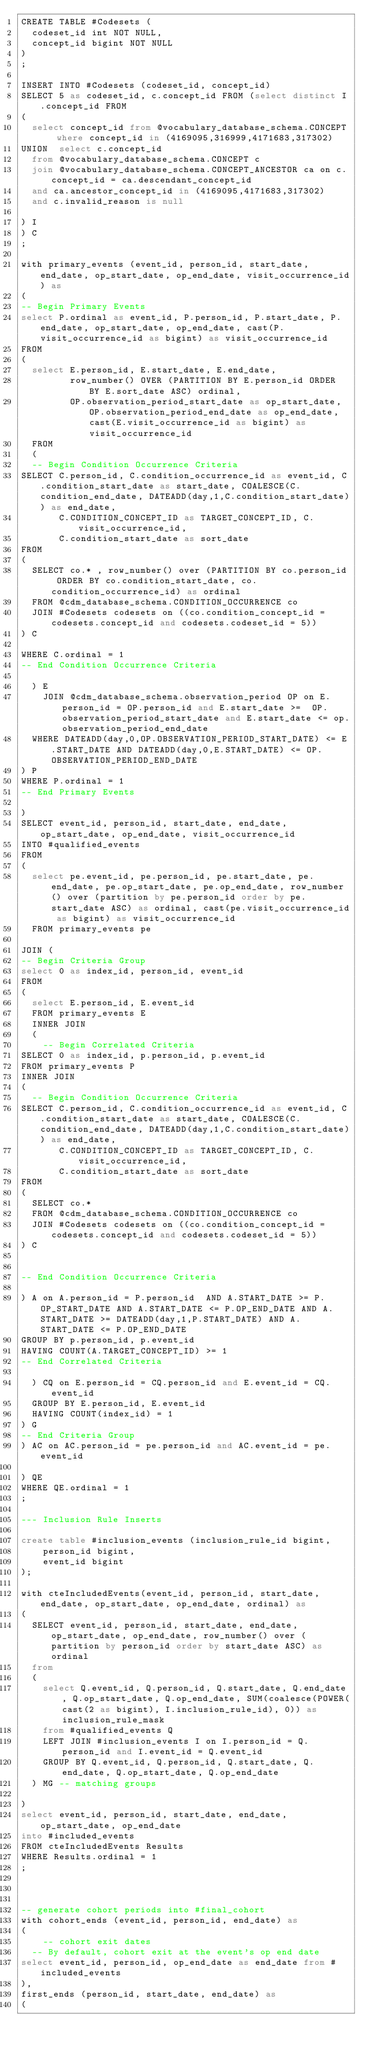<code> <loc_0><loc_0><loc_500><loc_500><_SQL_>CREATE TABLE #Codesets (
  codeset_id int NOT NULL,
  concept_id bigint NOT NULL
)
;

INSERT INTO #Codesets (codeset_id, concept_id)
SELECT 5 as codeset_id, c.concept_id FROM (select distinct I.concept_id FROM
( 
  select concept_id from @vocabulary_database_schema.CONCEPT where concept_id in (4169095,316999,4171683,317302)
UNION  select c.concept_id
  from @vocabulary_database_schema.CONCEPT c
  join @vocabulary_database_schema.CONCEPT_ANCESTOR ca on c.concept_id = ca.descendant_concept_id
  and ca.ancestor_concept_id in (4169095,4171683,317302)
  and c.invalid_reason is null

) I
) C
;

with primary_events (event_id, person_id, start_date, end_date, op_start_date, op_end_date, visit_occurrence_id) as
(
-- Begin Primary Events
select P.ordinal as event_id, P.person_id, P.start_date, P.end_date, op_start_date, op_end_date, cast(P.visit_occurrence_id as bigint) as visit_occurrence_id
FROM
(
  select E.person_id, E.start_date, E.end_date,
         row_number() OVER (PARTITION BY E.person_id ORDER BY E.sort_date ASC) ordinal,
         OP.observation_period_start_date as op_start_date, OP.observation_period_end_date as op_end_date, cast(E.visit_occurrence_id as bigint) as visit_occurrence_id
  FROM 
  (
  -- Begin Condition Occurrence Criteria
SELECT C.person_id, C.condition_occurrence_id as event_id, C.condition_start_date as start_date, COALESCE(C.condition_end_date, DATEADD(day,1,C.condition_start_date)) as end_date,
       C.CONDITION_CONCEPT_ID as TARGET_CONCEPT_ID, C.visit_occurrence_id,
       C.condition_start_date as sort_date
FROM 
(
  SELECT co.* , row_number() over (PARTITION BY co.person_id ORDER BY co.condition_start_date, co.condition_occurrence_id) as ordinal
  FROM @cdm_database_schema.CONDITION_OCCURRENCE co
  JOIN #Codesets codesets on ((co.condition_concept_id = codesets.concept_id and codesets.codeset_id = 5))
) C

WHERE C.ordinal = 1
-- End Condition Occurrence Criteria

  ) E
	JOIN @cdm_database_schema.observation_period OP on E.person_id = OP.person_id and E.start_date >=  OP.observation_period_start_date and E.start_date <= op.observation_period_end_date
  WHERE DATEADD(day,0,OP.OBSERVATION_PERIOD_START_DATE) <= E.START_DATE AND DATEADD(day,0,E.START_DATE) <= OP.OBSERVATION_PERIOD_END_DATE
) P
WHERE P.ordinal = 1
-- End Primary Events

)
SELECT event_id, person_id, start_date, end_date, op_start_date, op_end_date, visit_occurrence_id
INTO #qualified_events
FROM 
(
  select pe.event_id, pe.person_id, pe.start_date, pe.end_date, pe.op_start_date, pe.op_end_date, row_number() over (partition by pe.person_id order by pe.start_date ASC) as ordinal, cast(pe.visit_occurrence_id as bigint) as visit_occurrence_id
  FROM primary_events pe
  
JOIN (
-- Begin Criteria Group
select 0 as index_id, person_id, event_id
FROM
(
  select E.person_id, E.event_id 
  FROM primary_events E
  INNER JOIN
  (
    -- Begin Correlated Criteria
SELECT 0 as index_id, p.person_id, p.event_id
FROM primary_events P
INNER JOIN
(
  -- Begin Condition Occurrence Criteria
SELECT C.person_id, C.condition_occurrence_id as event_id, C.condition_start_date as start_date, COALESCE(C.condition_end_date, DATEADD(day,1,C.condition_start_date)) as end_date,
       C.CONDITION_CONCEPT_ID as TARGET_CONCEPT_ID, C.visit_occurrence_id,
       C.condition_start_date as sort_date
FROM 
(
  SELECT co.* 
  FROM @cdm_database_schema.CONDITION_OCCURRENCE co
  JOIN #Codesets codesets on ((co.condition_concept_id = codesets.concept_id and codesets.codeset_id = 5))
) C


-- End Condition Occurrence Criteria

) A on A.person_id = P.person_id  AND A.START_DATE >= P.OP_START_DATE AND A.START_DATE <= P.OP_END_DATE AND A.START_DATE >= DATEADD(day,1,P.START_DATE) AND A.START_DATE <= P.OP_END_DATE
GROUP BY p.person_id, p.event_id
HAVING COUNT(A.TARGET_CONCEPT_ID) >= 1
-- End Correlated Criteria

  ) CQ on E.person_id = CQ.person_id and E.event_id = CQ.event_id
  GROUP BY E.person_id, E.event_id
  HAVING COUNT(index_id) = 1
) G
-- End Criteria Group
) AC on AC.person_id = pe.person_id and AC.event_id = pe.event_id

) QE
WHERE QE.ordinal = 1
;

--- Inclusion Rule Inserts

create table #inclusion_events (inclusion_rule_id bigint,
	person_id bigint,
	event_id bigint
);

with cteIncludedEvents(event_id, person_id, start_date, end_date, op_start_date, op_end_date, ordinal) as
(
  SELECT event_id, person_id, start_date, end_date, op_start_date, op_end_date, row_number() over (partition by person_id order by start_date ASC) as ordinal
  from
  (
    select Q.event_id, Q.person_id, Q.start_date, Q.end_date, Q.op_start_date, Q.op_end_date, SUM(coalesce(POWER(cast(2 as bigint), I.inclusion_rule_id), 0)) as inclusion_rule_mask
    from #qualified_events Q
    LEFT JOIN #inclusion_events I on I.person_id = Q.person_id and I.event_id = Q.event_id
    GROUP BY Q.event_id, Q.person_id, Q.start_date, Q.end_date, Q.op_start_date, Q.op_end_date
  ) MG -- matching groups

)
select event_id, person_id, start_date, end_date, op_start_date, op_end_date
into #included_events
FROM cteIncludedEvents Results
WHERE Results.ordinal = 1
;



-- generate cohort periods into #final_cohort
with cohort_ends (event_id, person_id, end_date) as
(
	-- cohort exit dates
  -- By default, cohort exit at the event's op end date
select event_id, person_id, op_end_date as end_date from #included_events
),
first_ends (person_id, start_date, end_date) as
(</code> 